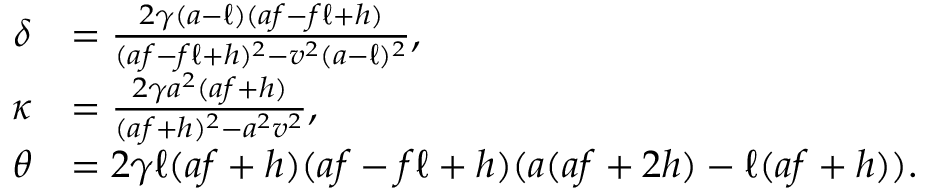<formula> <loc_0><loc_0><loc_500><loc_500>\begin{array} { r l } { \delta } & { = \frac { 2 \gamma ( a - \ell ) ( a f - f \ell + h ) } { ( a f - f \ell + h ) ^ { 2 } - v ^ { 2 } ( a - \ell ) ^ { 2 } } , } \\ { \kappa } & { = \frac { 2 \gamma a ^ { 2 } ( a f + h ) } { ( a f + h ) ^ { 2 } - a ^ { 2 } v ^ { 2 } } , } \\ { \theta } & { = 2 \gamma \ell ( a f + h ) ( a f - f \ell + h ) ( a ( a f + 2 h ) - \ell ( a f + h ) ) . } \end{array}</formula> 